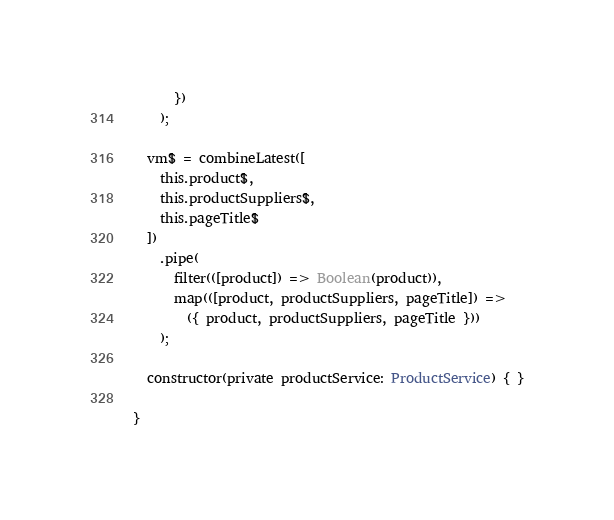Convert code to text. <code><loc_0><loc_0><loc_500><loc_500><_TypeScript_>      })
    );

  vm$ = combineLatest([
    this.product$,
    this.productSuppliers$,
    this.pageTitle$
  ])
    .pipe(
      filter(([product]) => Boolean(product)),
      map(([product, productSuppliers, pageTitle]) =>
        ({ product, productSuppliers, pageTitle }))
    );

  constructor(private productService: ProductService) { }

}
</code> 